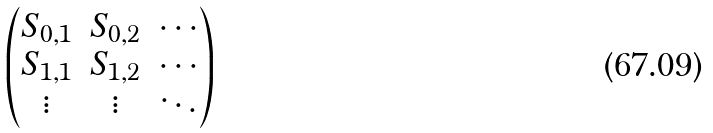Convert formula to latex. <formula><loc_0><loc_0><loc_500><loc_500>\begin{pmatrix} S _ { 0 , 1 } & S _ { 0 , 2 } & \cdots \\ S _ { 1 , 1 } & S _ { 1 , 2 } & \cdots \\ \vdots & \vdots & \ddots \end{pmatrix}</formula> 